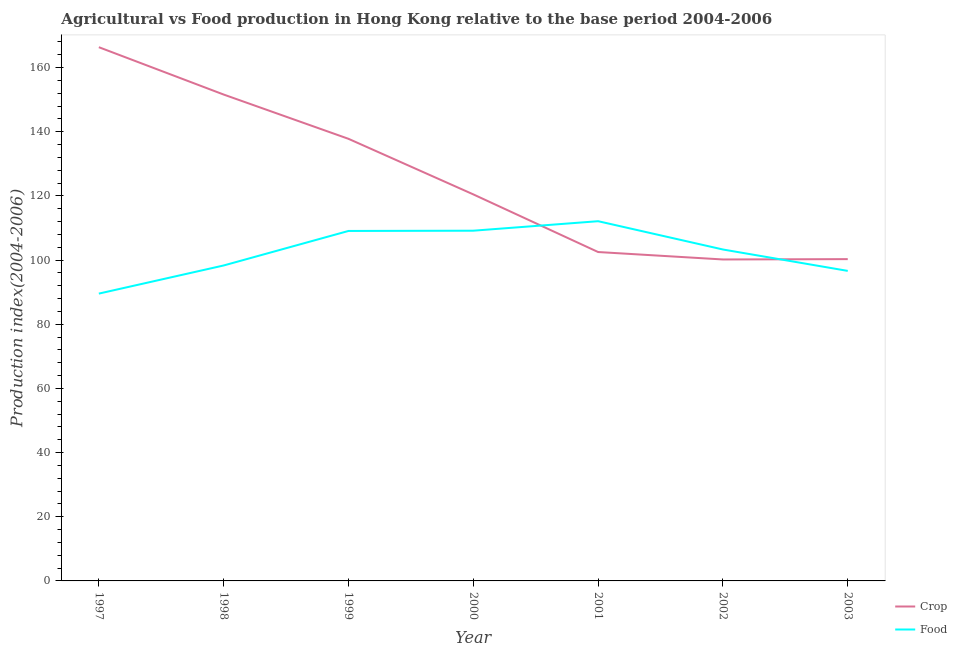What is the food production index in 1999?
Provide a short and direct response. 109.09. Across all years, what is the maximum crop production index?
Keep it short and to the point. 166.37. Across all years, what is the minimum food production index?
Keep it short and to the point. 89.56. In which year was the food production index maximum?
Make the answer very short. 2001. What is the total crop production index in the graph?
Offer a very short reply. 879.31. What is the difference between the food production index in 2000 and that in 2001?
Your answer should be compact. -2.96. What is the difference between the crop production index in 1997 and the food production index in 2001?
Provide a succinct answer. 54.24. What is the average crop production index per year?
Your answer should be compact. 125.62. In the year 1997, what is the difference between the crop production index and food production index?
Provide a short and direct response. 76.81. What is the ratio of the food production index in 1999 to that in 2001?
Your answer should be very brief. 0.97. What is the difference between the highest and the second highest crop production index?
Give a very brief answer. 14.76. What is the difference between the highest and the lowest crop production index?
Your answer should be compact. 66.17. In how many years, is the crop production index greater than the average crop production index taken over all years?
Your answer should be compact. 3. Is the sum of the food production index in 1997 and 2002 greater than the maximum crop production index across all years?
Provide a short and direct response. Yes. Is the food production index strictly less than the crop production index over the years?
Give a very brief answer. No. How many lines are there?
Provide a succinct answer. 2. What is the difference between two consecutive major ticks on the Y-axis?
Ensure brevity in your answer.  20. Are the values on the major ticks of Y-axis written in scientific E-notation?
Offer a terse response. No. What is the title of the graph?
Your answer should be very brief. Agricultural vs Food production in Hong Kong relative to the base period 2004-2006. What is the label or title of the Y-axis?
Give a very brief answer. Production index(2004-2006). What is the Production index(2004-2006) in Crop in 1997?
Provide a short and direct response. 166.37. What is the Production index(2004-2006) of Food in 1997?
Offer a very short reply. 89.56. What is the Production index(2004-2006) in Crop in 1998?
Give a very brief answer. 151.61. What is the Production index(2004-2006) of Food in 1998?
Your answer should be very brief. 98.33. What is the Production index(2004-2006) of Crop in 1999?
Your response must be concise. 137.81. What is the Production index(2004-2006) of Food in 1999?
Provide a short and direct response. 109.09. What is the Production index(2004-2006) of Crop in 2000?
Your answer should be compact. 120.49. What is the Production index(2004-2006) in Food in 2000?
Give a very brief answer. 109.17. What is the Production index(2004-2006) in Crop in 2001?
Make the answer very short. 102.52. What is the Production index(2004-2006) in Food in 2001?
Ensure brevity in your answer.  112.13. What is the Production index(2004-2006) in Crop in 2002?
Make the answer very short. 100.2. What is the Production index(2004-2006) of Food in 2002?
Keep it short and to the point. 103.31. What is the Production index(2004-2006) of Crop in 2003?
Offer a terse response. 100.31. What is the Production index(2004-2006) in Food in 2003?
Provide a short and direct response. 96.64. Across all years, what is the maximum Production index(2004-2006) of Crop?
Keep it short and to the point. 166.37. Across all years, what is the maximum Production index(2004-2006) in Food?
Provide a short and direct response. 112.13. Across all years, what is the minimum Production index(2004-2006) in Crop?
Offer a very short reply. 100.2. Across all years, what is the minimum Production index(2004-2006) of Food?
Ensure brevity in your answer.  89.56. What is the total Production index(2004-2006) of Crop in the graph?
Make the answer very short. 879.31. What is the total Production index(2004-2006) of Food in the graph?
Provide a short and direct response. 718.23. What is the difference between the Production index(2004-2006) in Crop in 1997 and that in 1998?
Provide a succinct answer. 14.76. What is the difference between the Production index(2004-2006) of Food in 1997 and that in 1998?
Offer a terse response. -8.77. What is the difference between the Production index(2004-2006) of Crop in 1997 and that in 1999?
Your answer should be compact. 28.56. What is the difference between the Production index(2004-2006) in Food in 1997 and that in 1999?
Offer a very short reply. -19.53. What is the difference between the Production index(2004-2006) of Crop in 1997 and that in 2000?
Give a very brief answer. 45.88. What is the difference between the Production index(2004-2006) in Food in 1997 and that in 2000?
Offer a very short reply. -19.61. What is the difference between the Production index(2004-2006) in Crop in 1997 and that in 2001?
Make the answer very short. 63.85. What is the difference between the Production index(2004-2006) in Food in 1997 and that in 2001?
Your response must be concise. -22.57. What is the difference between the Production index(2004-2006) in Crop in 1997 and that in 2002?
Provide a short and direct response. 66.17. What is the difference between the Production index(2004-2006) in Food in 1997 and that in 2002?
Ensure brevity in your answer.  -13.75. What is the difference between the Production index(2004-2006) of Crop in 1997 and that in 2003?
Give a very brief answer. 66.06. What is the difference between the Production index(2004-2006) of Food in 1997 and that in 2003?
Your answer should be compact. -7.08. What is the difference between the Production index(2004-2006) in Food in 1998 and that in 1999?
Ensure brevity in your answer.  -10.76. What is the difference between the Production index(2004-2006) of Crop in 1998 and that in 2000?
Offer a terse response. 31.12. What is the difference between the Production index(2004-2006) in Food in 1998 and that in 2000?
Provide a succinct answer. -10.84. What is the difference between the Production index(2004-2006) in Crop in 1998 and that in 2001?
Provide a succinct answer. 49.09. What is the difference between the Production index(2004-2006) of Food in 1998 and that in 2001?
Your answer should be compact. -13.8. What is the difference between the Production index(2004-2006) in Crop in 1998 and that in 2002?
Offer a very short reply. 51.41. What is the difference between the Production index(2004-2006) in Food in 1998 and that in 2002?
Provide a short and direct response. -4.98. What is the difference between the Production index(2004-2006) of Crop in 1998 and that in 2003?
Give a very brief answer. 51.3. What is the difference between the Production index(2004-2006) in Food in 1998 and that in 2003?
Your response must be concise. 1.69. What is the difference between the Production index(2004-2006) in Crop in 1999 and that in 2000?
Give a very brief answer. 17.32. What is the difference between the Production index(2004-2006) of Food in 1999 and that in 2000?
Offer a terse response. -0.08. What is the difference between the Production index(2004-2006) of Crop in 1999 and that in 2001?
Your answer should be very brief. 35.29. What is the difference between the Production index(2004-2006) in Food in 1999 and that in 2001?
Your answer should be very brief. -3.04. What is the difference between the Production index(2004-2006) in Crop in 1999 and that in 2002?
Offer a terse response. 37.61. What is the difference between the Production index(2004-2006) of Food in 1999 and that in 2002?
Your answer should be very brief. 5.78. What is the difference between the Production index(2004-2006) of Crop in 1999 and that in 2003?
Give a very brief answer. 37.5. What is the difference between the Production index(2004-2006) in Food in 1999 and that in 2003?
Make the answer very short. 12.45. What is the difference between the Production index(2004-2006) of Crop in 2000 and that in 2001?
Make the answer very short. 17.97. What is the difference between the Production index(2004-2006) in Food in 2000 and that in 2001?
Offer a very short reply. -2.96. What is the difference between the Production index(2004-2006) of Crop in 2000 and that in 2002?
Offer a very short reply. 20.29. What is the difference between the Production index(2004-2006) of Food in 2000 and that in 2002?
Give a very brief answer. 5.86. What is the difference between the Production index(2004-2006) in Crop in 2000 and that in 2003?
Offer a terse response. 20.18. What is the difference between the Production index(2004-2006) of Food in 2000 and that in 2003?
Give a very brief answer. 12.53. What is the difference between the Production index(2004-2006) in Crop in 2001 and that in 2002?
Your response must be concise. 2.32. What is the difference between the Production index(2004-2006) of Food in 2001 and that in 2002?
Your answer should be very brief. 8.82. What is the difference between the Production index(2004-2006) in Crop in 2001 and that in 2003?
Give a very brief answer. 2.21. What is the difference between the Production index(2004-2006) of Food in 2001 and that in 2003?
Keep it short and to the point. 15.49. What is the difference between the Production index(2004-2006) in Crop in 2002 and that in 2003?
Give a very brief answer. -0.11. What is the difference between the Production index(2004-2006) in Food in 2002 and that in 2003?
Provide a short and direct response. 6.67. What is the difference between the Production index(2004-2006) in Crop in 1997 and the Production index(2004-2006) in Food in 1998?
Give a very brief answer. 68.04. What is the difference between the Production index(2004-2006) of Crop in 1997 and the Production index(2004-2006) of Food in 1999?
Offer a terse response. 57.28. What is the difference between the Production index(2004-2006) in Crop in 1997 and the Production index(2004-2006) in Food in 2000?
Ensure brevity in your answer.  57.2. What is the difference between the Production index(2004-2006) in Crop in 1997 and the Production index(2004-2006) in Food in 2001?
Make the answer very short. 54.24. What is the difference between the Production index(2004-2006) of Crop in 1997 and the Production index(2004-2006) of Food in 2002?
Give a very brief answer. 63.06. What is the difference between the Production index(2004-2006) of Crop in 1997 and the Production index(2004-2006) of Food in 2003?
Your answer should be very brief. 69.73. What is the difference between the Production index(2004-2006) of Crop in 1998 and the Production index(2004-2006) of Food in 1999?
Your response must be concise. 42.52. What is the difference between the Production index(2004-2006) in Crop in 1998 and the Production index(2004-2006) in Food in 2000?
Give a very brief answer. 42.44. What is the difference between the Production index(2004-2006) of Crop in 1998 and the Production index(2004-2006) of Food in 2001?
Keep it short and to the point. 39.48. What is the difference between the Production index(2004-2006) of Crop in 1998 and the Production index(2004-2006) of Food in 2002?
Your answer should be compact. 48.3. What is the difference between the Production index(2004-2006) of Crop in 1998 and the Production index(2004-2006) of Food in 2003?
Your answer should be compact. 54.97. What is the difference between the Production index(2004-2006) in Crop in 1999 and the Production index(2004-2006) in Food in 2000?
Offer a very short reply. 28.64. What is the difference between the Production index(2004-2006) in Crop in 1999 and the Production index(2004-2006) in Food in 2001?
Provide a succinct answer. 25.68. What is the difference between the Production index(2004-2006) of Crop in 1999 and the Production index(2004-2006) of Food in 2002?
Give a very brief answer. 34.5. What is the difference between the Production index(2004-2006) of Crop in 1999 and the Production index(2004-2006) of Food in 2003?
Ensure brevity in your answer.  41.17. What is the difference between the Production index(2004-2006) of Crop in 2000 and the Production index(2004-2006) of Food in 2001?
Keep it short and to the point. 8.36. What is the difference between the Production index(2004-2006) in Crop in 2000 and the Production index(2004-2006) in Food in 2002?
Your answer should be compact. 17.18. What is the difference between the Production index(2004-2006) in Crop in 2000 and the Production index(2004-2006) in Food in 2003?
Offer a terse response. 23.85. What is the difference between the Production index(2004-2006) of Crop in 2001 and the Production index(2004-2006) of Food in 2002?
Your answer should be compact. -0.79. What is the difference between the Production index(2004-2006) in Crop in 2001 and the Production index(2004-2006) in Food in 2003?
Offer a very short reply. 5.88. What is the difference between the Production index(2004-2006) in Crop in 2002 and the Production index(2004-2006) in Food in 2003?
Offer a very short reply. 3.56. What is the average Production index(2004-2006) in Crop per year?
Your answer should be compact. 125.62. What is the average Production index(2004-2006) in Food per year?
Keep it short and to the point. 102.6. In the year 1997, what is the difference between the Production index(2004-2006) of Crop and Production index(2004-2006) of Food?
Ensure brevity in your answer.  76.81. In the year 1998, what is the difference between the Production index(2004-2006) of Crop and Production index(2004-2006) of Food?
Keep it short and to the point. 53.28. In the year 1999, what is the difference between the Production index(2004-2006) of Crop and Production index(2004-2006) of Food?
Your response must be concise. 28.72. In the year 2000, what is the difference between the Production index(2004-2006) of Crop and Production index(2004-2006) of Food?
Give a very brief answer. 11.32. In the year 2001, what is the difference between the Production index(2004-2006) of Crop and Production index(2004-2006) of Food?
Give a very brief answer. -9.61. In the year 2002, what is the difference between the Production index(2004-2006) in Crop and Production index(2004-2006) in Food?
Offer a very short reply. -3.11. In the year 2003, what is the difference between the Production index(2004-2006) in Crop and Production index(2004-2006) in Food?
Offer a terse response. 3.67. What is the ratio of the Production index(2004-2006) in Crop in 1997 to that in 1998?
Keep it short and to the point. 1.1. What is the ratio of the Production index(2004-2006) of Food in 1997 to that in 1998?
Keep it short and to the point. 0.91. What is the ratio of the Production index(2004-2006) in Crop in 1997 to that in 1999?
Provide a succinct answer. 1.21. What is the ratio of the Production index(2004-2006) in Food in 1997 to that in 1999?
Provide a succinct answer. 0.82. What is the ratio of the Production index(2004-2006) of Crop in 1997 to that in 2000?
Offer a very short reply. 1.38. What is the ratio of the Production index(2004-2006) in Food in 1997 to that in 2000?
Make the answer very short. 0.82. What is the ratio of the Production index(2004-2006) in Crop in 1997 to that in 2001?
Your response must be concise. 1.62. What is the ratio of the Production index(2004-2006) of Food in 1997 to that in 2001?
Make the answer very short. 0.8. What is the ratio of the Production index(2004-2006) in Crop in 1997 to that in 2002?
Ensure brevity in your answer.  1.66. What is the ratio of the Production index(2004-2006) in Food in 1997 to that in 2002?
Provide a succinct answer. 0.87. What is the ratio of the Production index(2004-2006) in Crop in 1997 to that in 2003?
Your answer should be compact. 1.66. What is the ratio of the Production index(2004-2006) in Food in 1997 to that in 2003?
Your answer should be very brief. 0.93. What is the ratio of the Production index(2004-2006) in Crop in 1998 to that in 1999?
Your response must be concise. 1.1. What is the ratio of the Production index(2004-2006) of Food in 1998 to that in 1999?
Your answer should be compact. 0.9. What is the ratio of the Production index(2004-2006) of Crop in 1998 to that in 2000?
Make the answer very short. 1.26. What is the ratio of the Production index(2004-2006) in Food in 1998 to that in 2000?
Your answer should be very brief. 0.9. What is the ratio of the Production index(2004-2006) of Crop in 1998 to that in 2001?
Give a very brief answer. 1.48. What is the ratio of the Production index(2004-2006) in Food in 1998 to that in 2001?
Ensure brevity in your answer.  0.88. What is the ratio of the Production index(2004-2006) of Crop in 1998 to that in 2002?
Keep it short and to the point. 1.51. What is the ratio of the Production index(2004-2006) of Food in 1998 to that in 2002?
Your answer should be very brief. 0.95. What is the ratio of the Production index(2004-2006) of Crop in 1998 to that in 2003?
Offer a very short reply. 1.51. What is the ratio of the Production index(2004-2006) in Food in 1998 to that in 2003?
Provide a short and direct response. 1.02. What is the ratio of the Production index(2004-2006) in Crop in 1999 to that in 2000?
Your answer should be very brief. 1.14. What is the ratio of the Production index(2004-2006) in Food in 1999 to that in 2000?
Offer a terse response. 1. What is the ratio of the Production index(2004-2006) of Crop in 1999 to that in 2001?
Keep it short and to the point. 1.34. What is the ratio of the Production index(2004-2006) in Food in 1999 to that in 2001?
Offer a very short reply. 0.97. What is the ratio of the Production index(2004-2006) in Crop in 1999 to that in 2002?
Keep it short and to the point. 1.38. What is the ratio of the Production index(2004-2006) of Food in 1999 to that in 2002?
Ensure brevity in your answer.  1.06. What is the ratio of the Production index(2004-2006) in Crop in 1999 to that in 2003?
Provide a succinct answer. 1.37. What is the ratio of the Production index(2004-2006) in Food in 1999 to that in 2003?
Your answer should be very brief. 1.13. What is the ratio of the Production index(2004-2006) of Crop in 2000 to that in 2001?
Ensure brevity in your answer.  1.18. What is the ratio of the Production index(2004-2006) of Food in 2000 to that in 2001?
Your answer should be very brief. 0.97. What is the ratio of the Production index(2004-2006) in Crop in 2000 to that in 2002?
Your response must be concise. 1.2. What is the ratio of the Production index(2004-2006) in Food in 2000 to that in 2002?
Provide a short and direct response. 1.06. What is the ratio of the Production index(2004-2006) of Crop in 2000 to that in 2003?
Offer a terse response. 1.2. What is the ratio of the Production index(2004-2006) in Food in 2000 to that in 2003?
Make the answer very short. 1.13. What is the ratio of the Production index(2004-2006) of Crop in 2001 to that in 2002?
Offer a terse response. 1.02. What is the ratio of the Production index(2004-2006) in Food in 2001 to that in 2002?
Ensure brevity in your answer.  1.09. What is the ratio of the Production index(2004-2006) in Crop in 2001 to that in 2003?
Give a very brief answer. 1.02. What is the ratio of the Production index(2004-2006) in Food in 2001 to that in 2003?
Provide a succinct answer. 1.16. What is the ratio of the Production index(2004-2006) of Crop in 2002 to that in 2003?
Keep it short and to the point. 1. What is the ratio of the Production index(2004-2006) in Food in 2002 to that in 2003?
Offer a terse response. 1.07. What is the difference between the highest and the second highest Production index(2004-2006) of Crop?
Offer a very short reply. 14.76. What is the difference between the highest and the second highest Production index(2004-2006) in Food?
Give a very brief answer. 2.96. What is the difference between the highest and the lowest Production index(2004-2006) in Crop?
Make the answer very short. 66.17. What is the difference between the highest and the lowest Production index(2004-2006) in Food?
Offer a terse response. 22.57. 